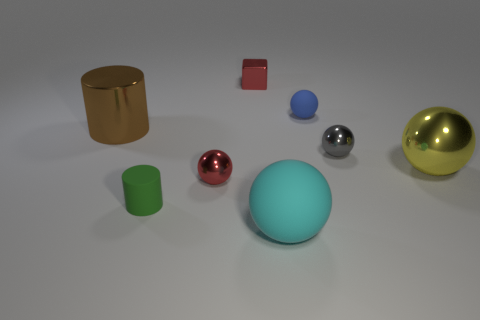Subtract all gray metallic spheres. How many spheres are left? 4 Subtract all cyan spheres. How many spheres are left? 4 Add 1 tiny cylinders. How many objects exist? 9 Subtract all balls. How many objects are left? 3 Subtract all purple balls. Subtract all yellow cubes. How many balls are left? 5 Subtract all small blue matte balls. Subtract all tiny cubes. How many objects are left? 6 Add 2 cyan balls. How many cyan balls are left? 3 Add 5 red things. How many red things exist? 7 Subtract 1 green cylinders. How many objects are left? 7 